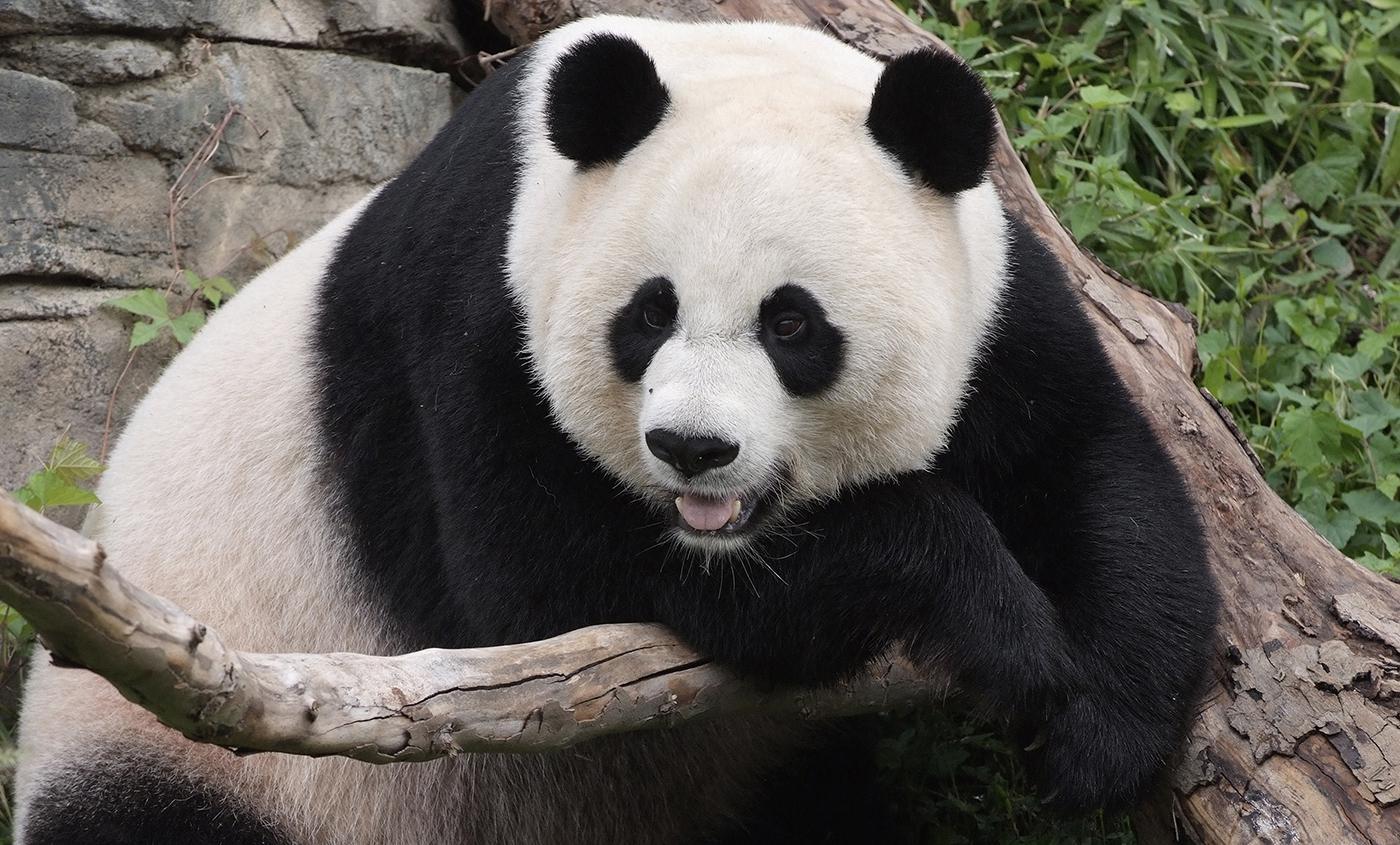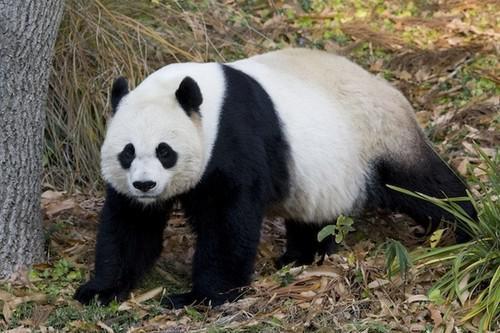The first image is the image on the left, the second image is the image on the right. Analyze the images presented: Is the assertion "There are two black and white panda bears" valid? Answer yes or no. Yes. The first image is the image on the left, the second image is the image on the right. Assess this claim about the two images: "One of the pandas is on all fours.". Correct or not? Answer yes or no. Yes. 